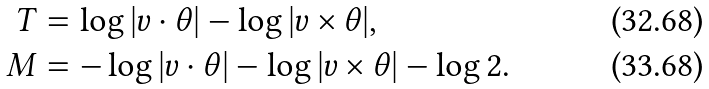<formula> <loc_0><loc_0><loc_500><loc_500>T & = \log | v \cdot \theta | - \log | v \times \theta | , \\ M & = - \log | v \cdot \theta | - \log | v \times \theta | - \log 2 .</formula> 